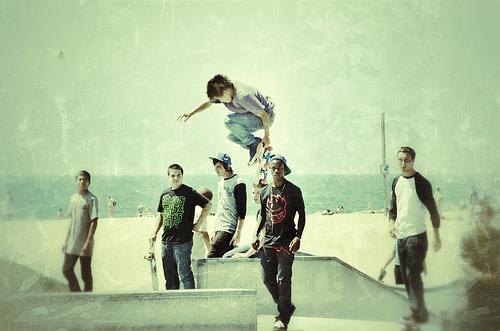How many people are in the picture?
Give a very brief answer. 6. 